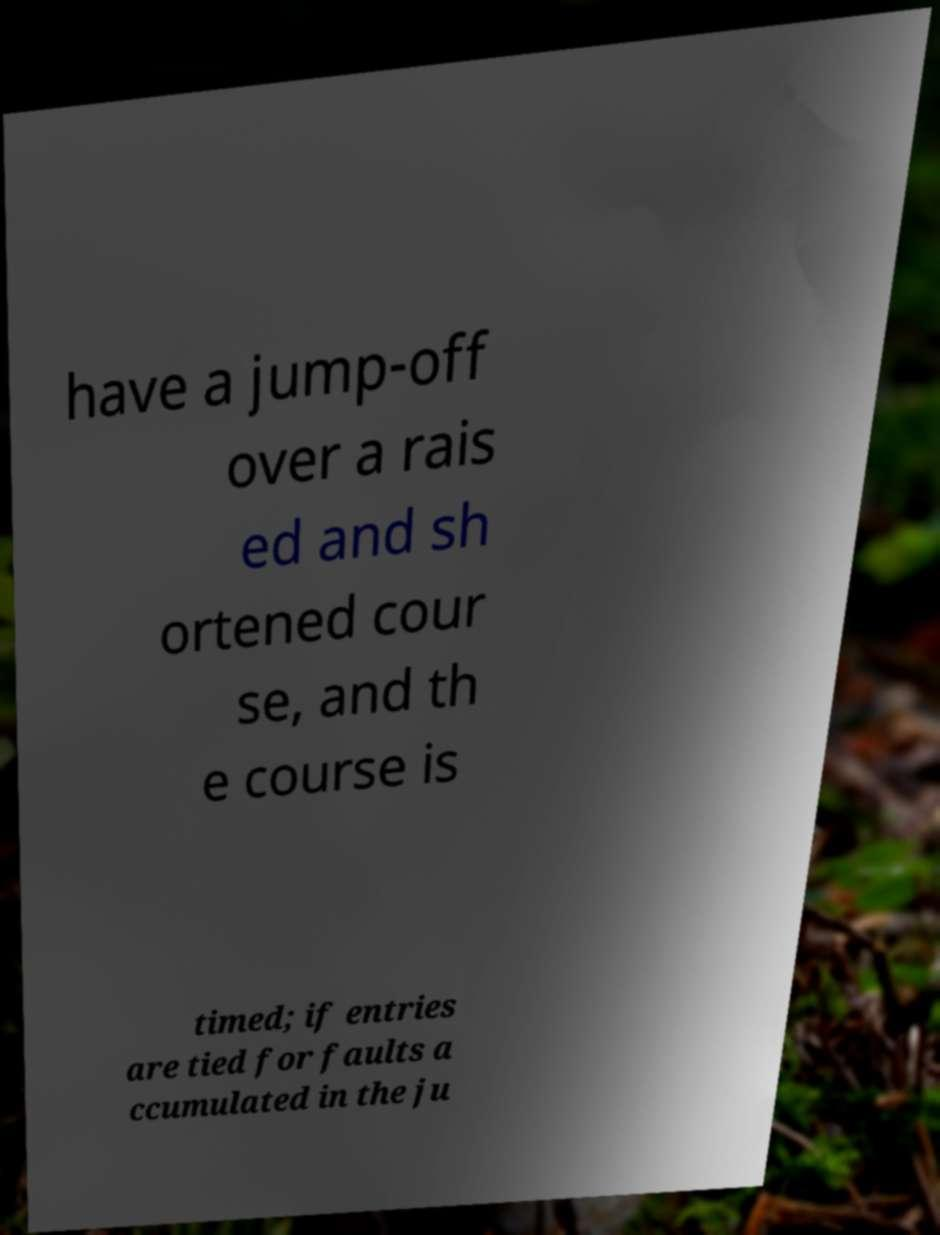Can you read and provide the text displayed in the image?This photo seems to have some interesting text. Can you extract and type it out for me? have a jump-off over a rais ed and sh ortened cour se, and th e course is timed; if entries are tied for faults a ccumulated in the ju 